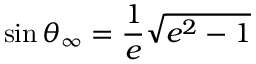Convert formula to latex. <formula><loc_0><loc_0><loc_500><loc_500>\sin \theta _ { \infty } = { \frac { 1 } { e } } { \sqrt { e ^ { 2 } - 1 } }</formula> 